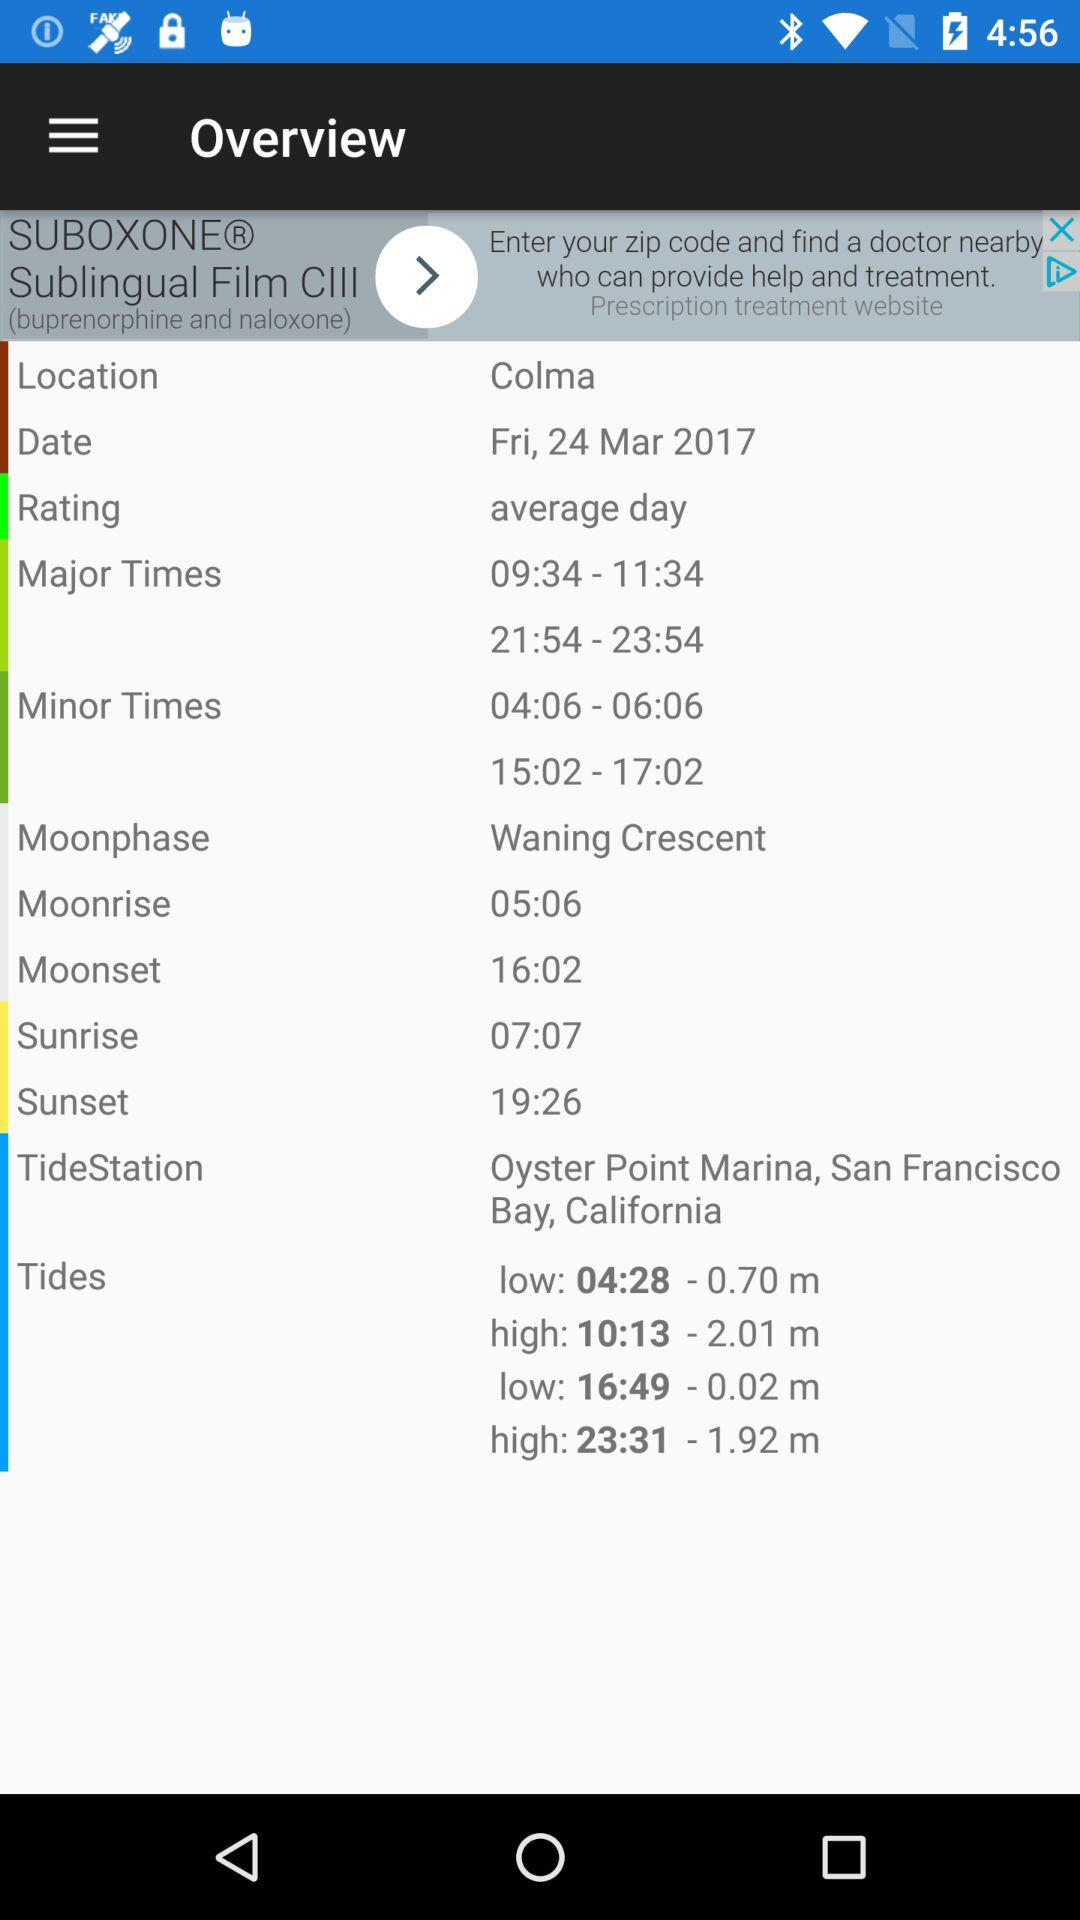What is the moonrise time? The moonrise time is 05:06. 